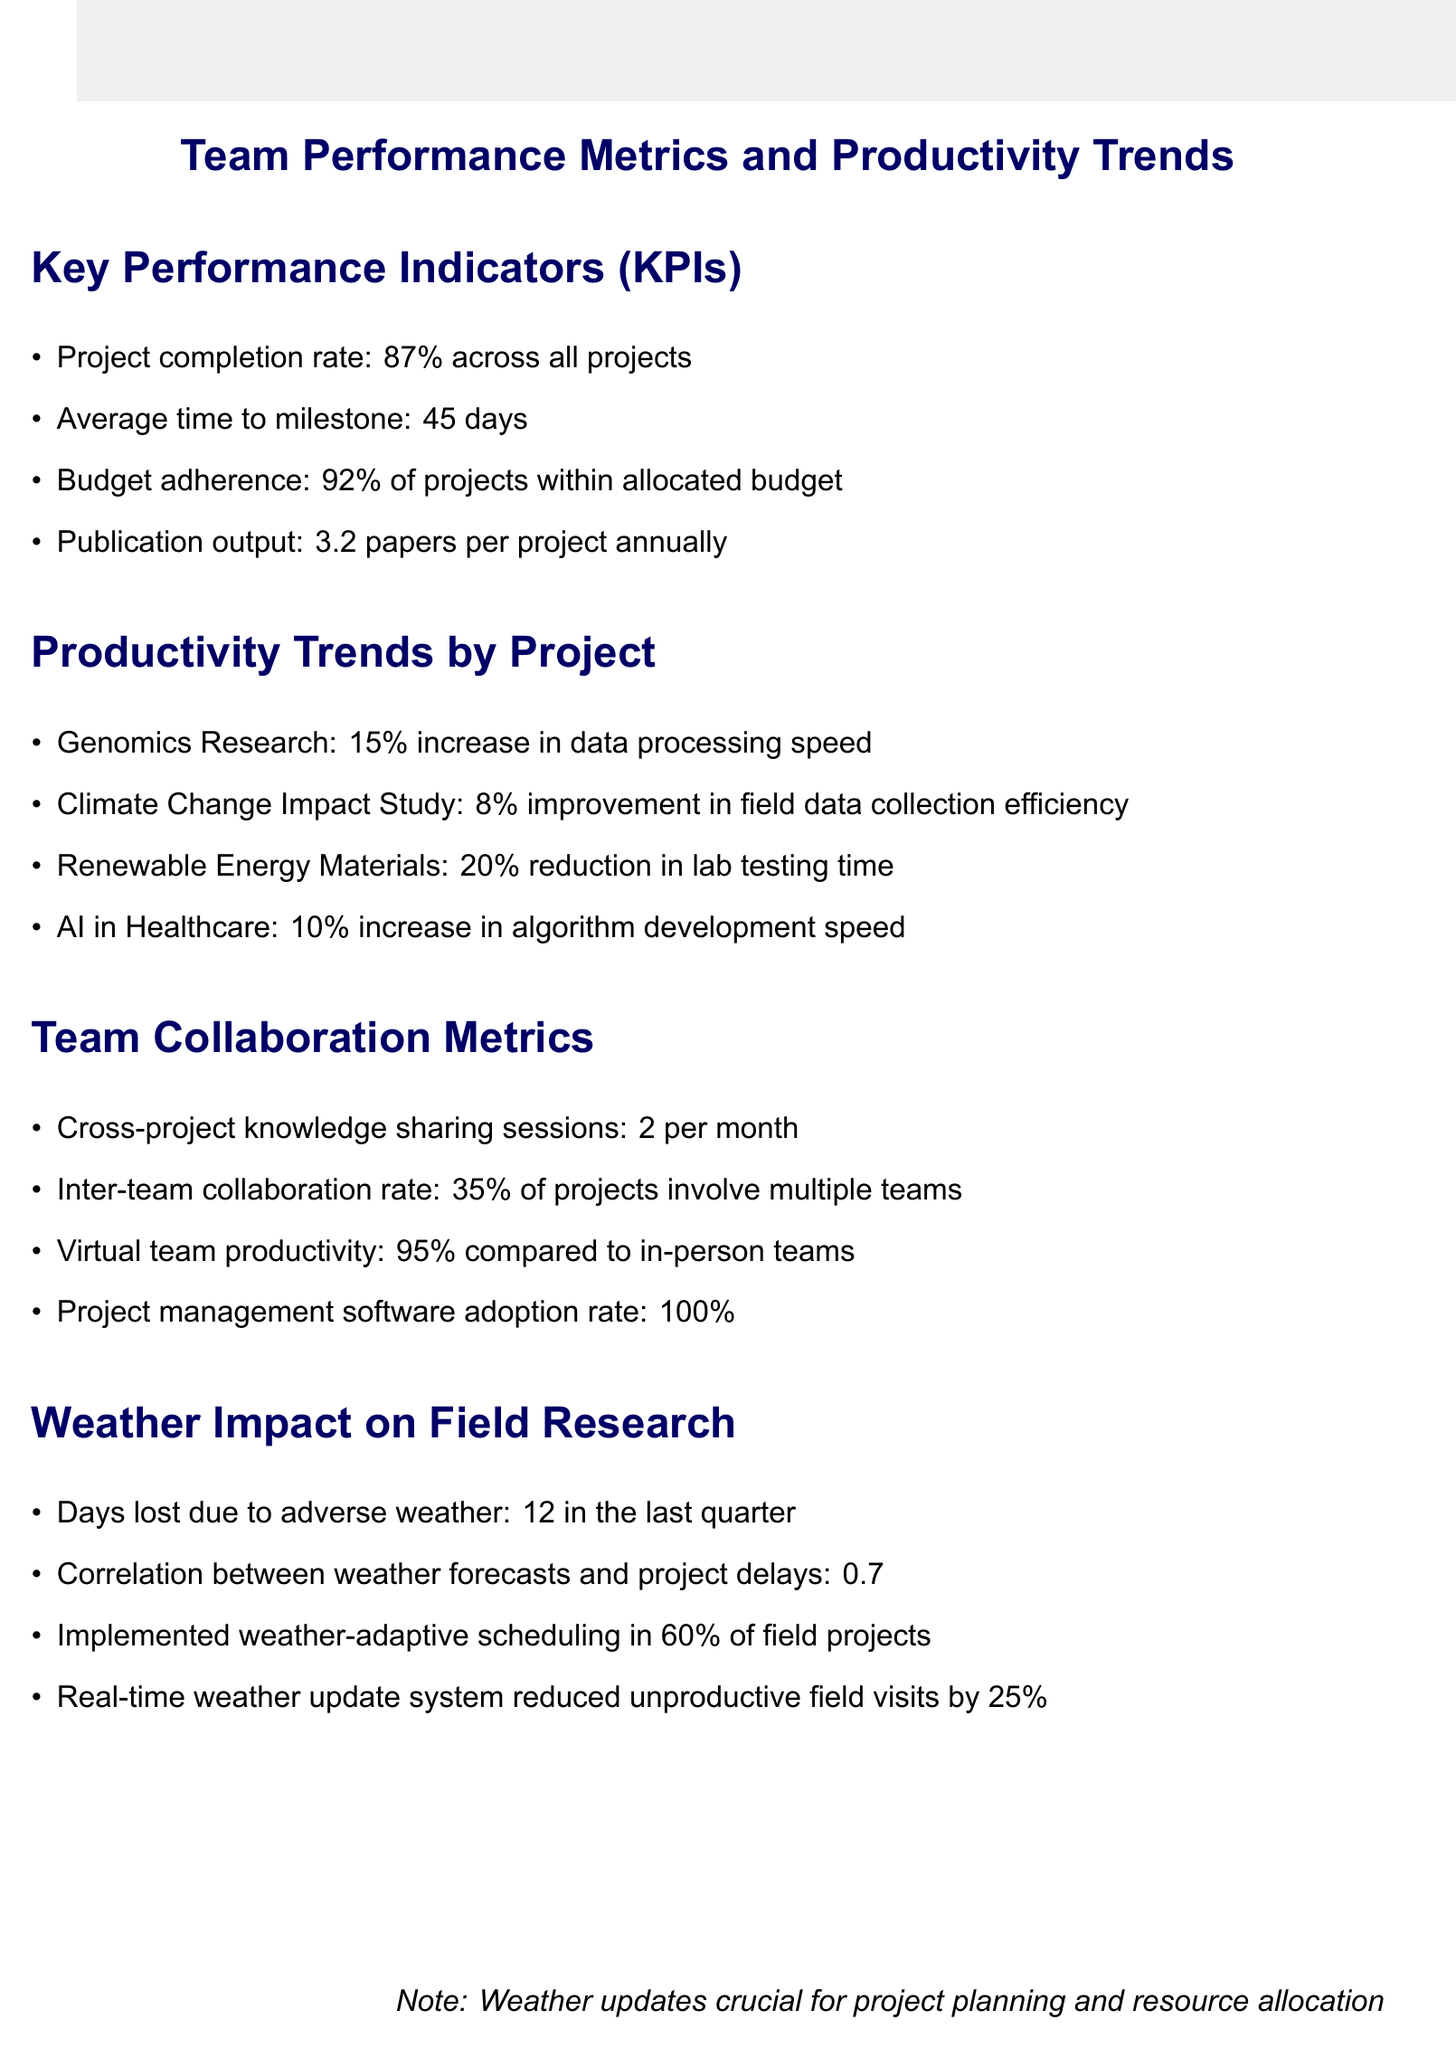What is the project completion rate? The project completion rate is a key performance indicator shown in the document, which informs about the percentage of projects completed successfully.
Answer: 87% What is the average time to milestone? The average time to milestone is listed under the Key Performance Indicators section, representing the average duration taken to reach significant project milestones.
Answer: 45 days Which project saw a 20% reduction in lab testing time? This question requires identifying the project that achieved this notable productivity trend as detailed in the relevant section of the document.
Answer: Renewable Energy Materials What percentage of projects implemented weather-adaptive scheduling? This details how many field projects made adjustments based on weather considerations, demonstrating the proactive measures taken to mitigate weather impact.
Answer: 60% What is the inter-team collaboration rate? This rate indicates how many projects involve multiple teams working together, providing insight into team dynamics and collaboration efforts.
Answer: 35% How many days were lost due to adverse weather in the last quarter? This figure highlights the impacts of weather on project timelines, a crucial aspect of field research projects as mentioned in the document.
Answer: 12 What is the publication output per project annually? The annual publication output indicates the research productivity level, reflecting efforts in knowledge dissemination from each project.
Answer: 3.2 papers What is the correlation between weather forecasts and project delays? This value illustrates the relationship between accurate weather forecasting and its effect on project timelines, a key aspect of planning for research projects.
Answer: 0.7 What is the virtual team productivity compared to in-person teams? This metric allows an understanding of how well virtual teams perform in comparison to those working in-person, showcasing the effectiveness of remote collaboration.
Answer: 95% 